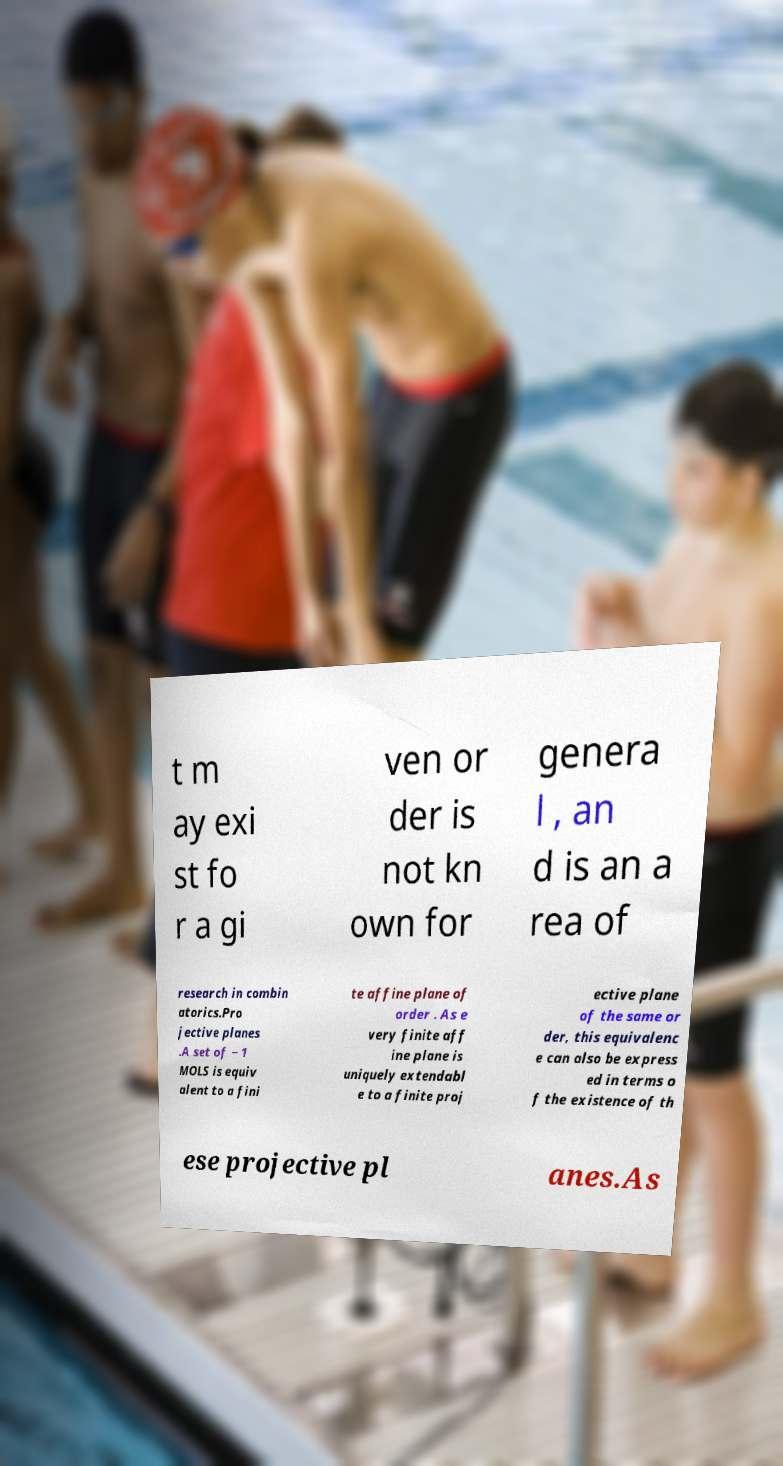Please read and relay the text visible in this image. What does it say? t m ay exi st fo r a gi ven or der is not kn own for genera l , an d is an a rea of research in combin atorics.Pro jective planes .A set of − 1 MOLS is equiv alent to a fini te affine plane of order . As e very finite aff ine plane is uniquely extendabl e to a finite proj ective plane of the same or der, this equivalenc e can also be express ed in terms o f the existence of th ese projective pl anes.As 